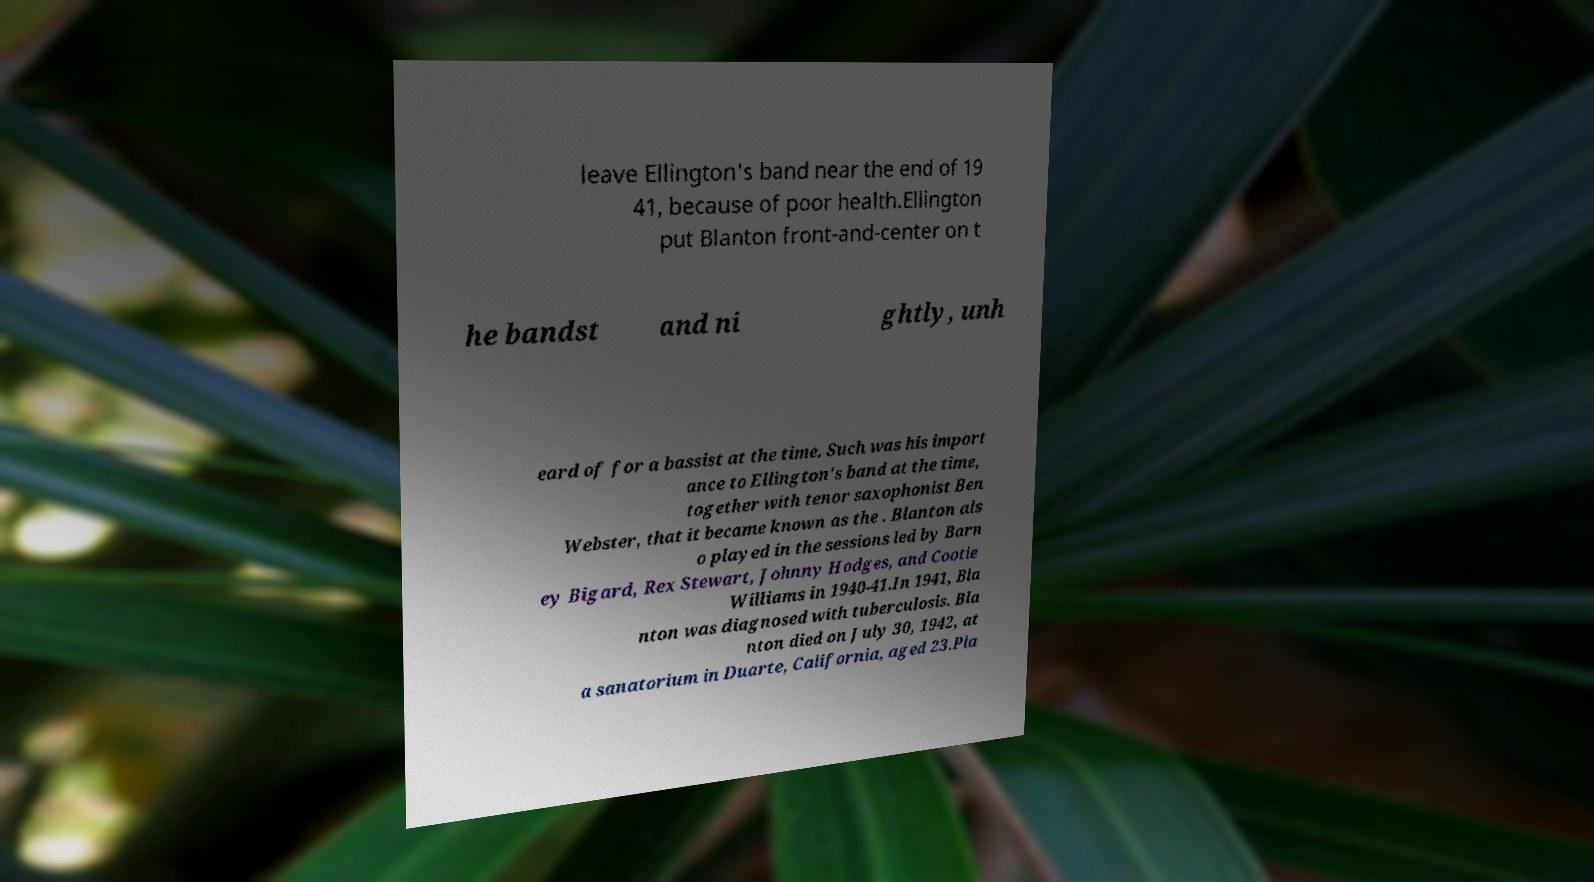Could you extract and type out the text from this image? leave Ellington's band near the end of 19 41, because of poor health.Ellington put Blanton front-and-center on t he bandst and ni ghtly, unh eard of for a bassist at the time. Such was his import ance to Ellington's band at the time, together with tenor saxophonist Ben Webster, that it became known as the . Blanton als o played in the sessions led by Barn ey Bigard, Rex Stewart, Johnny Hodges, and Cootie Williams in 1940-41.In 1941, Bla nton was diagnosed with tuberculosis. Bla nton died on July 30, 1942, at a sanatorium in Duarte, California, aged 23.Pla 